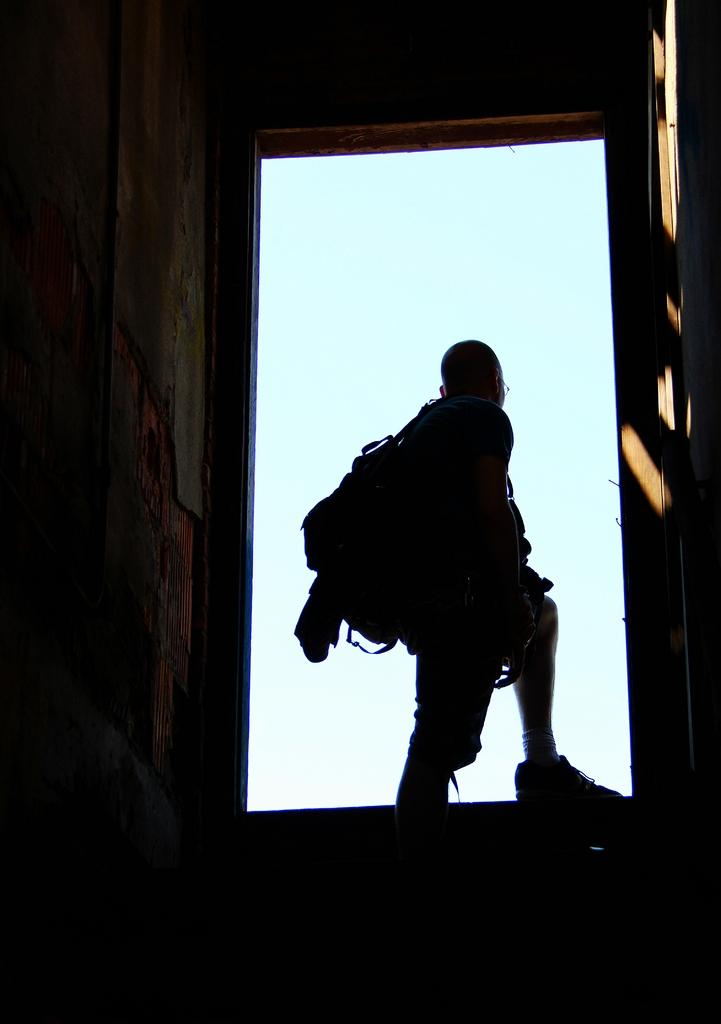Who or what is present in the image? There is a person in the image. What is the person doing in the image? The person is standing. What is the person carrying in the image? The person is carrying a backpack. What can be seen in the background of the image? There is a wall in the image. What type of corn is growing in the image? There is no corn present in the image. 